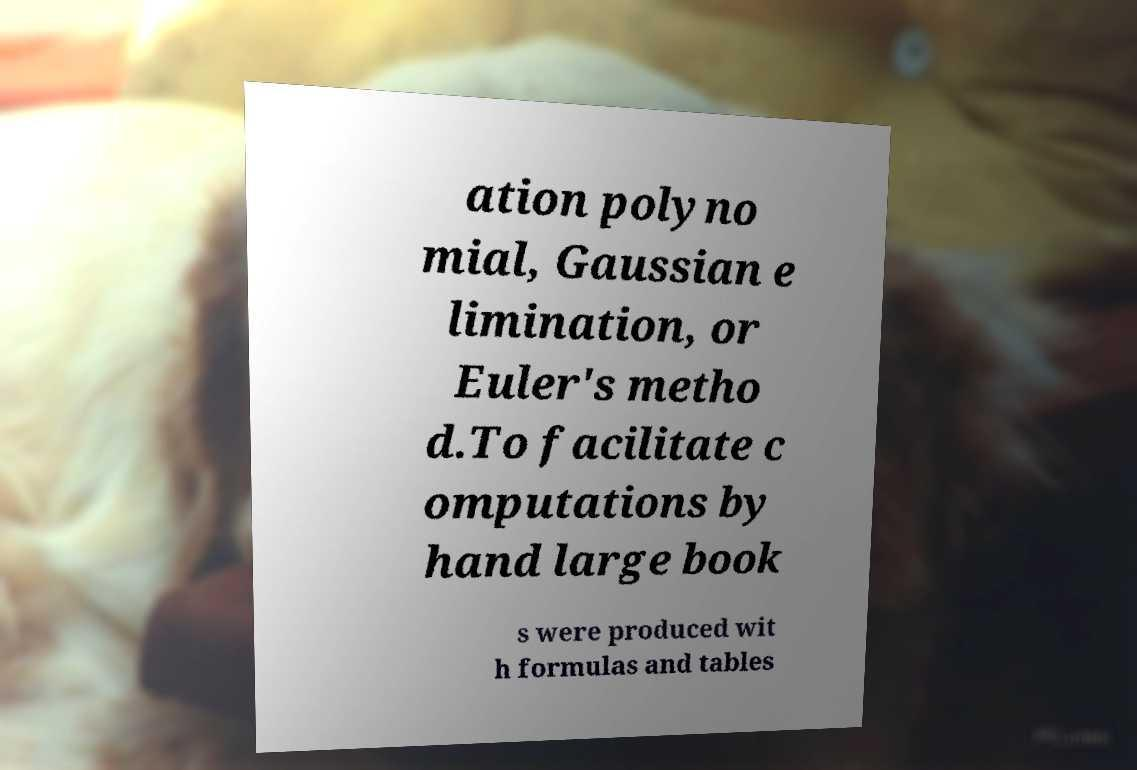Please identify and transcribe the text found in this image. ation polyno mial, Gaussian e limination, or Euler's metho d.To facilitate c omputations by hand large book s were produced wit h formulas and tables 